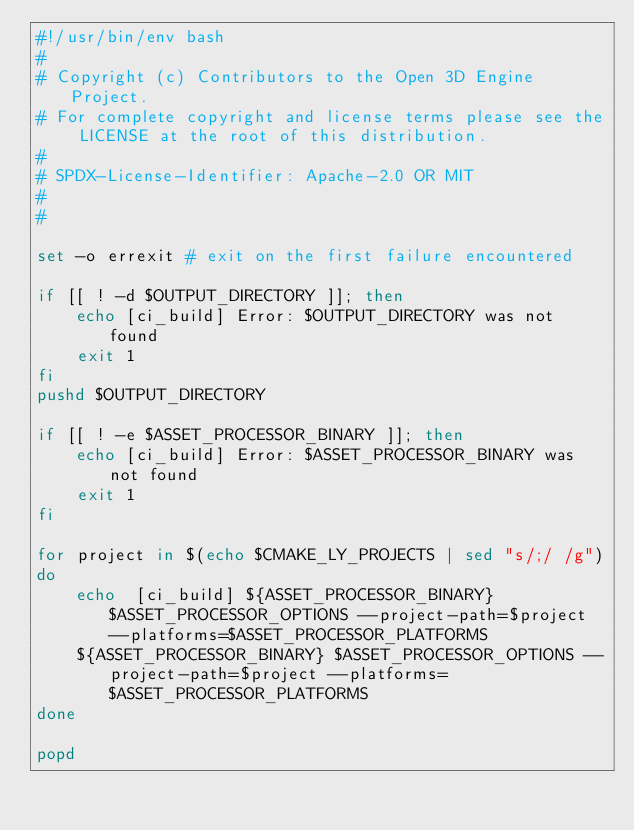<code> <loc_0><loc_0><loc_500><loc_500><_Bash_>#!/usr/bin/env bash
#
# Copyright (c) Contributors to the Open 3D Engine Project.
# For complete copyright and license terms please see the LICENSE at the root of this distribution.
#
# SPDX-License-Identifier: Apache-2.0 OR MIT
#
#

set -o errexit # exit on the first failure encountered

if [[ ! -d $OUTPUT_DIRECTORY ]]; then
    echo [ci_build] Error: $OUTPUT_DIRECTORY was not found
    exit 1
fi
pushd $OUTPUT_DIRECTORY

if [[ ! -e $ASSET_PROCESSOR_BINARY ]]; then
    echo [ci_build] Error: $ASSET_PROCESSOR_BINARY was not found
    exit 1
fi

for project in $(echo $CMAKE_LY_PROJECTS | sed "s/;/ /g")
do
    echo  [ci_build] ${ASSET_PROCESSOR_BINARY} $ASSET_PROCESSOR_OPTIONS --project-path=$project --platforms=$ASSET_PROCESSOR_PLATFORMS
    ${ASSET_PROCESSOR_BINARY} $ASSET_PROCESSOR_OPTIONS --project-path=$project --platforms=$ASSET_PROCESSOR_PLATFORMS
done

popd
</code> 